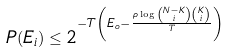<formula> <loc_0><loc_0><loc_500><loc_500>P ( E _ { i } ) \leq 2 ^ { - T \left ( E _ { o } - \frac { \rho \log \binom { N - K } { i } \binom { K } { i } } { T } \right ) }</formula> 